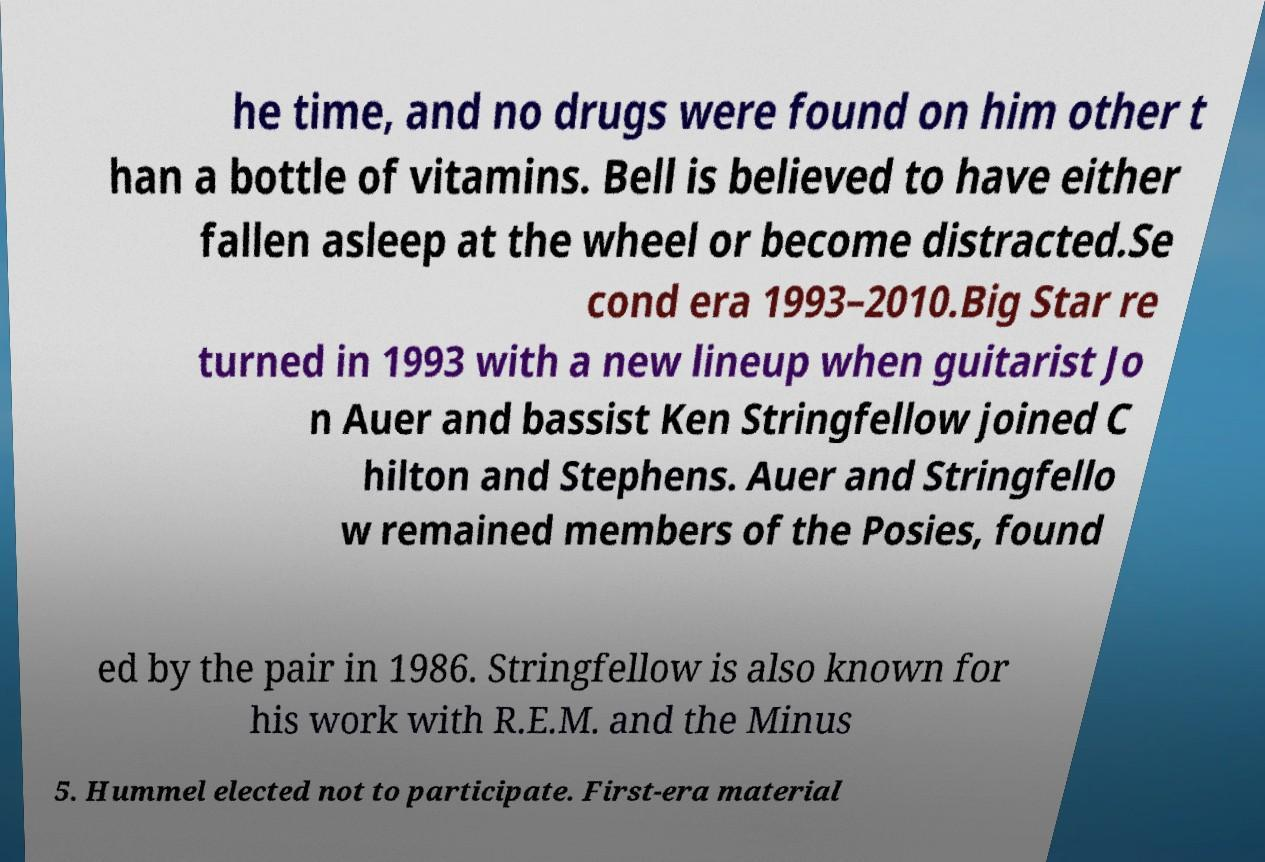Please read and relay the text visible in this image. What does it say? he time, and no drugs were found on him other t han a bottle of vitamins. Bell is believed to have either fallen asleep at the wheel or become distracted.Se cond era 1993–2010.Big Star re turned in 1993 with a new lineup when guitarist Jo n Auer and bassist Ken Stringfellow joined C hilton and Stephens. Auer and Stringfello w remained members of the Posies, found ed by the pair in 1986. Stringfellow is also known for his work with R.E.M. and the Minus 5. Hummel elected not to participate. First-era material 